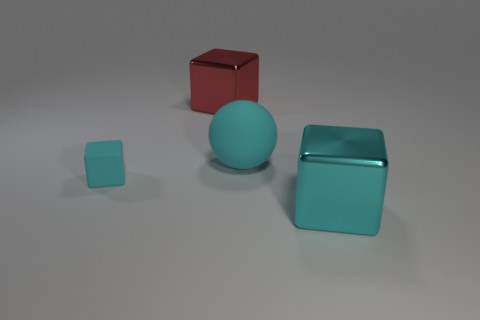Which object appears closest to the perspective of the viewer? From the perspective of the viewer, the small aqua cube appears to be the closest object. It is positioned in the foreground of the image, giving it prominence in the viewer's field of view. Does the lighting have any effect on the objects' appearance? Yes, the lighting in the image creates subtle shadows behind the objects, contributing to a sense of depth and dimensionality. Moreover, the glossy finish of the red cube reflects the light, distinguishing it from the other objects with matte surfaces. 